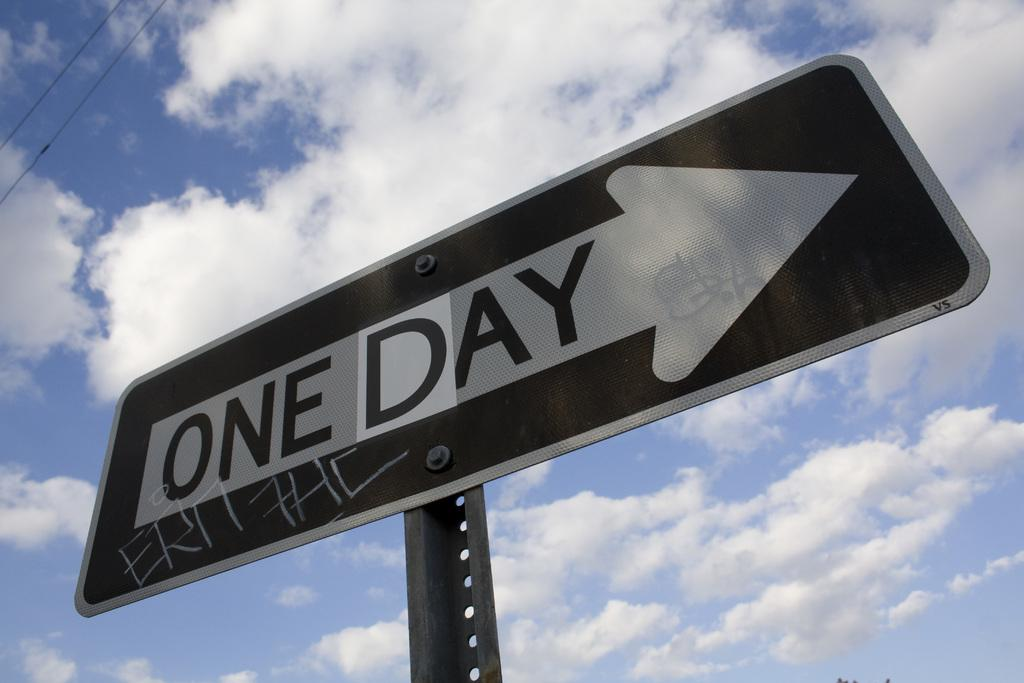<image>
Give a short and clear explanation of the subsequent image. A one-way sign has been altered to say "one day". 